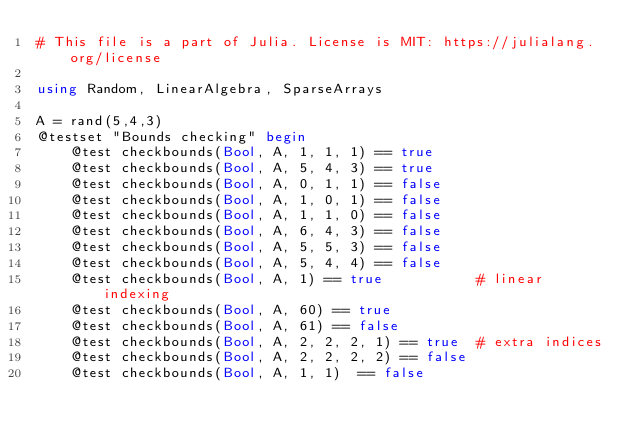<code> <loc_0><loc_0><loc_500><loc_500><_Julia_># This file is a part of Julia. License is MIT: https://julialang.org/license

using Random, LinearAlgebra, SparseArrays

A = rand(5,4,3)
@testset "Bounds checking" begin
    @test checkbounds(Bool, A, 1, 1, 1) == true
    @test checkbounds(Bool, A, 5, 4, 3) == true
    @test checkbounds(Bool, A, 0, 1, 1) == false
    @test checkbounds(Bool, A, 1, 0, 1) == false
    @test checkbounds(Bool, A, 1, 1, 0) == false
    @test checkbounds(Bool, A, 6, 4, 3) == false
    @test checkbounds(Bool, A, 5, 5, 3) == false
    @test checkbounds(Bool, A, 5, 4, 4) == false
    @test checkbounds(Bool, A, 1) == true           # linear indexing
    @test checkbounds(Bool, A, 60) == true
    @test checkbounds(Bool, A, 61) == false
    @test checkbounds(Bool, A, 2, 2, 2, 1) == true  # extra indices
    @test checkbounds(Bool, A, 2, 2, 2, 2) == false
    @test checkbounds(Bool, A, 1, 1)  == false</code> 